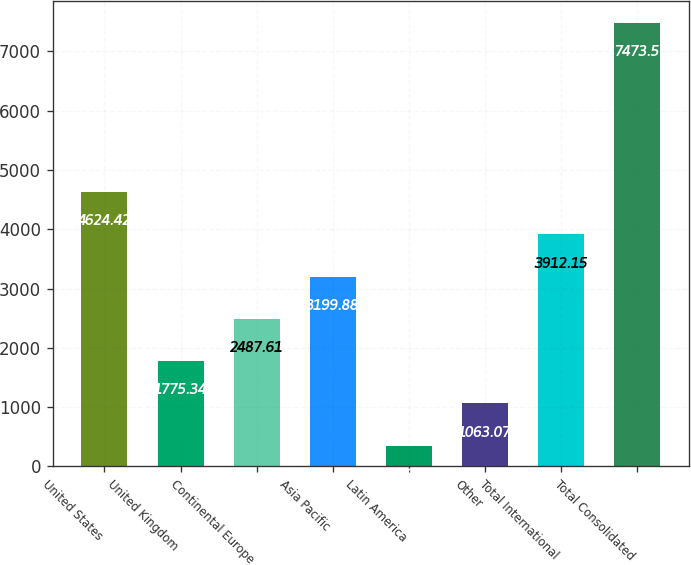<chart> <loc_0><loc_0><loc_500><loc_500><bar_chart><fcel>United States<fcel>United Kingdom<fcel>Continental Europe<fcel>Asia Pacific<fcel>Latin America<fcel>Other<fcel>Total International<fcel>Total Consolidated<nl><fcel>4624.42<fcel>1775.34<fcel>2487.61<fcel>3199.88<fcel>350.8<fcel>1063.07<fcel>3912.15<fcel>7473.5<nl></chart> 